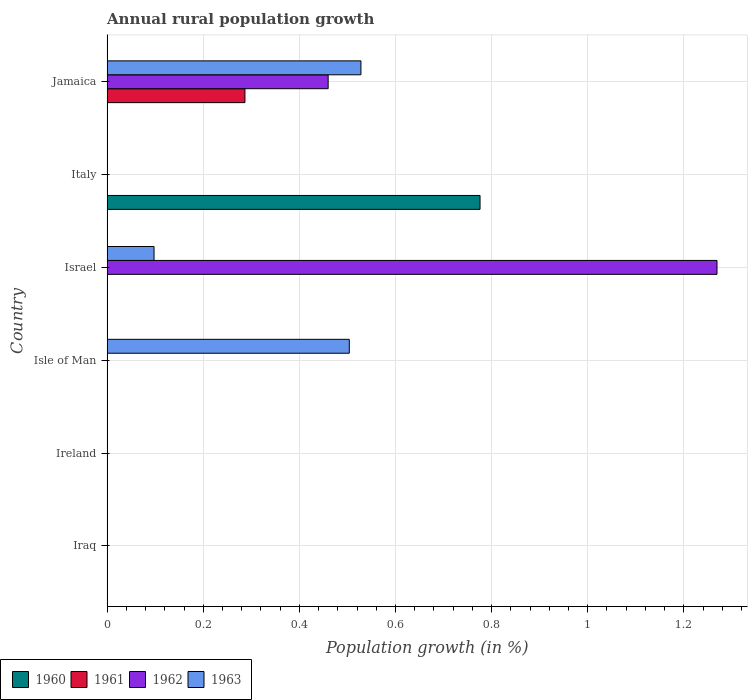How many different coloured bars are there?
Provide a short and direct response. 4. Are the number of bars per tick equal to the number of legend labels?
Ensure brevity in your answer.  No. Are the number of bars on each tick of the Y-axis equal?
Your answer should be compact. No. How many bars are there on the 2nd tick from the top?
Offer a terse response. 1. What is the label of the 3rd group of bars from the top?
Ensure brevity in your answer.  Israel. What is the percentage of rural population growth in 1960 in Jamaica?
Offer a very short reply. 0. Across all countries, what is the maximum percentage of rural population growth in 1962?
Ensure brevity in your answer.  1.27. In which country was the percentage of rural population growth in 1961 maximum?
Provide a succinct answer. Jamaica. What is the total percentage of rural population growth in 1961 in the graph?
Make the answer very short. 0.29. What is the difference between the percentage of rural population growth in 1963 in Israel and that in Jamaica?
Your answer should be compact. -0.43. What is the difference between the percentage of rural population growth in 1961 in Jamaica and the percentage of rural population growth in 1963 in Iraq?
Offer a very short reply. 0.29. What is the average percentage of rural population growth in 1960 per country?
Provide a short and direct response. 0.13. What is the difference between the highest and the second highest percentage of rural population growth in 1963?
Provide a short and direct response. 0.02. What is the difference between the highest and the lowest percentage of rural population growth in 1963?
Make the answer very short. 0.53. Is it the case that in every country, the sum of the percentage of rural population growth in 1963 and percentage of rural population growth in 1961 is greater than the sum of percentage of rural population growth in 1962 and percentage of rural population growth in 1960?
Ensure brevity in your answer.  No. Is it the case that in every country, the sum of the percentage of rural population growth in 1962 and percentage of rural population growth in 1961 is greater than the percentage of rural population growth in 1963?
Offer a terse response. No. How many countries are there in the graph?
Give a very brief answer. 6. What is the difference between two consecutive major ticks on the X-axis?
Your answer should be compact. 0.2. Does the graph contain any zero values?
Keep it short and to the point. Yes. Does the graph contain grids?
Provide a short and direct response. Yes. Where does the legend appear in the graph?
Give a very brief answer. Bottom left. How are the legend labels stacked?
Your answer should be compact. Horizontal. What is the title of the graph?
Provide a short and direct response. Annual rural population growth. Does "1985" appear as one of the legend labels in the graph?
Provide a short and direct response. No. What is the label or title of the X-axis?
Provide a short and direct response. Population growth (in %). What is the Population growth (in %) of 1960 in Iraq?
Make the answer very short. 0. What is the Population growth (in %) of 1962 in Iraq?
Offer a very short reply. 0. What is the Population growth (in %) of 1963 in Iraq?
Your response must be concise. 0. What is the Population growth (in %) of 1962 in Ireland?
Keep it short and to the point. 0. What is the Population growth (in %) of 1963 in Ireland?
Offer a very short reply. 0. What is the Population growth (in %) in 1960 in Isle of Man?
Your answer should be very brief. 0. What is the Population growth (in %) of 1961 in Isle of Man?
Your answer should be very brief. 0. What is the Population growth (in %) of 1962 in Isle of Man?
Make the answer very short. 0. What is the Population growth (in %) in 1963 in Isle of Man?
Keep it short and to the point. 0.5. What is the Population growth (in %) in 1960 in Israel?
Provide a succinct answer. 0. What is the Population growth (in %) in 1961 in Israel?
Keep it short and to the point. 0. What is the Population growth (in %) of 1962 in Israel?
Offer a very short reply. 1.27. What is the Population growth (in %) in 1963 in Israel?
Provide a succinct answer. 0.1. What is the Population growth (in %) of 1960 in Italy?
Make the answer very short. 0.78. What is the Population growth (in %) of 1961 in Italy?
Provide a short and direct response. 0. What is the Population growth (in %) of 1962 in Italy?
Provide a short and direct response. 0. What is the Population growth (in %) in 1961 in Jamaica?
Keep it short and to the point. 0.29. What is the Population growth (in %) of 1962 in Jamaica?
Offer a very short reply. 0.46. What is the Population growth (in %) of 1963 in Jamaica?
Ensure brevity in your answer.  0.53. Across all countries, what is the maximum Population growth (in %) of 1960?
Offer a terse response. 0.78. Across all countries, what is the maximum Population growth (in %) of 1961?
Make the answer very short. 0.29. Across all countries, what is the maximum Population growth (in %) of 1962?
Give a very brief answer. 1.27. Across all countries, what is the maximum Population growth (in %) in 1963?
Give a very brief answer. 0.53. Across all countries, what is the minimum Population growth (in %) in 1963?
Keep it short and to the point. 0. What is the total Population growth (in %) in 1960 in the graph?
Your answer should be compact. 0.78. What is the total Population growth (in %) in 1961 in the graph?
Your answer should be very brief. 0.29. What is the total Population growth (in %) of 1962 in the graph?
Your answer should be compact. 1.73. What is the total Population growth (in %) in 1963 in the graph?
Your answer should be very brief. 1.13. What is the difference between the Population growth (in %) of 1963 in Isle of Man and that in Israel?
Give a very brief answer. 0.41. What is the difference between the Population growth (in %) of 1963 in Isle of Man and that in Jamaica?
Offer a terse response. -0.02. What is the difference between the Population growth (in %) of 1962 in Israel and that in Jamaica?
Ensure brevity in your answer.  0.81. What is the difference between the Population growth (in %) of 1963 in Israel and that in Jamaica?
Your answer should be compact. -0.43. What is the difference between the Population growth (in %) of 1962 in Israel and the Population growth (in %) of 1963 in Jamaica?
Your answer should be very brief. 0.74. What is the difference between the Population growth (in %) of 1960 in Italy and the Population growth (in %) of 1961 in Jamaica?
Your response must be concise. 0.49. What is the difference between the Population growth (in %) of 1960 in Italy and the Population growth (in %) of 1962 in Jamaica?
Offer a very short reply. 0.32. What is the difference between the Population growth (in %) of 1960 in Italy and the Population growth (in %) of 1963 in Jamaica?
Provide a short and direct response. 0.25. What is the average Population growth (in %) of 1960 per country?
Give a very brief answer. 0.13. What is the average Population growth (in %) in 1961 per country?
Make the answer very short. 0.05. What is the average Population growth (in %) in 1962 per country?
Your answer should be very brief. 0.29. What is the average Population growth (in %) in 1963 per country?
Give a very brief answer. 0.19. What is the difference between the Population growth (in %) in 1962 and Population growth (in %) in 1963 in Israel?
Your answer should be very brief. 1.17. What is the difference between the Population growth (in %) of 1961 and Population growth (in %) of 1962 in Jamaica?
Keep it short and to the point. -0.17. What is the difference between the Population growth (in %) of 1961 and Population growth (in %) of 1963 in Jamaica?
Your answer should be very brief. -0.24. What is the difference between the Population growth (in %) of 1962 and Population growth (in %) of 1963 in Jamaica?
Provide a succinct answer. -0.07. What is the ratio of the Population growth (in %) of 1963 in Isle of Man to that in Israel?
Your answer should be very brief. 5.16. What is the ratio of the Population growth (in %) in 1963 in Isle of Man to that in Jamaica?
Ensure brevity in your answer.  0.95. What is the ratio of the Population growth (in %) in 1962 in Israel to that in Jamaica?
Your response must be concise. 2.76. What is the ratio of the Population growth (in %) of 1963 in Israel to that in Jamaica?
Make the answer very short. 0.18. What is the difference between the highest and the second highest Population growth (in %) of 1963?
Provide a short and direct response. 0.02. What is the difference between the highest and the lowest Population growth (in %) in 1960?
Provide a succinct answer. 0.78. What is the difference between the highest and the lowest Population growth (in %) in 1961?
Your answer should be compact. 0.29. What is the difference between the highest and the lowest Population growth (in %) of 1962?
Keep it short and to the point. 1.27. What is the difference between the highest and the lowest Population growth (in %) in 1963?
Offer a very short reply. 0.53. 